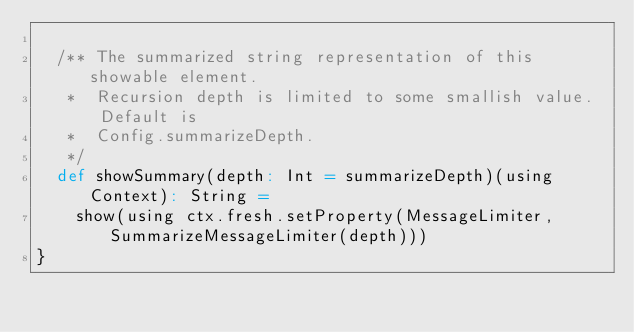Convert code to text. <code><loc_0><loc_0><loc_500><loc_500><_Scala_>
  /** The summarized string representation of this showable element.
   *  Recursion depth is limited to some smallish value. Default is
   *  Config.summarizeDepth.
   */
  def showSummary(depth: Int = summarizeDepth)(using Context): String =
    show(using ctx.fresh.setProperty(MessageLimiter, SummarizeMessageLimiter(depth)))
}
</code> 